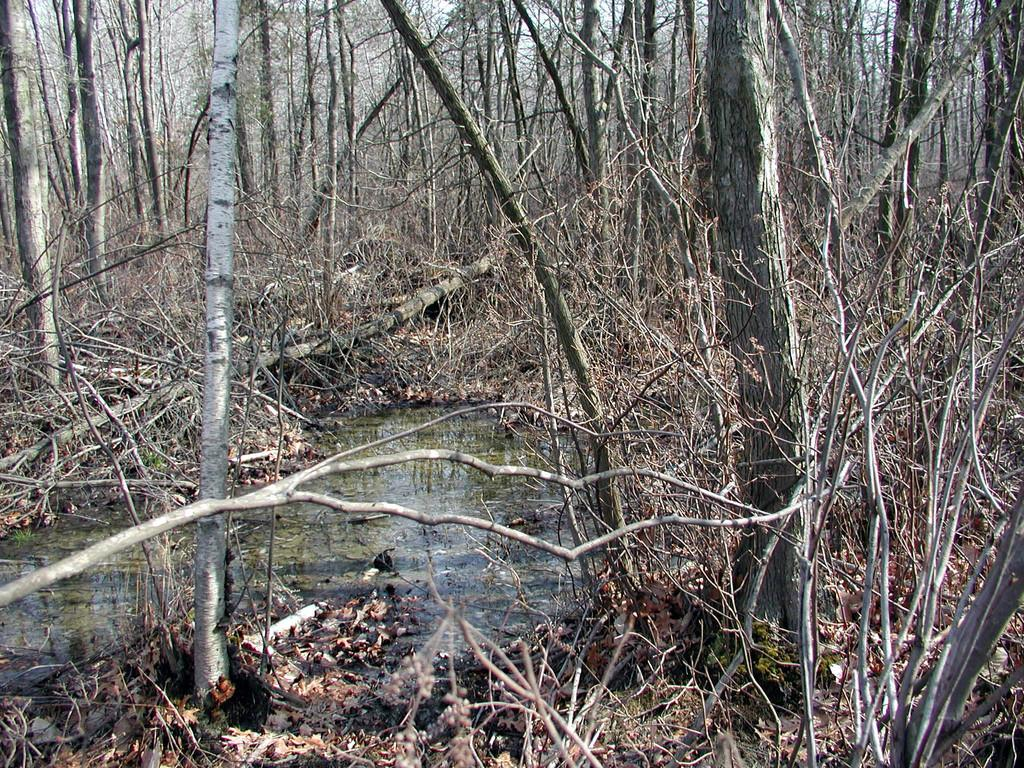What is visible in the image? There is water and trees visible in the image. Can you describe the water in the image? The water is visible, but its specific characteristics are not mentioned in the facts. What type of vegetation is present in the image? Trees are present in the image. How many plastic legs can be seen supporting the trees in the image? There is no mention of plastic legs or any artificial support for the trees in the image. 